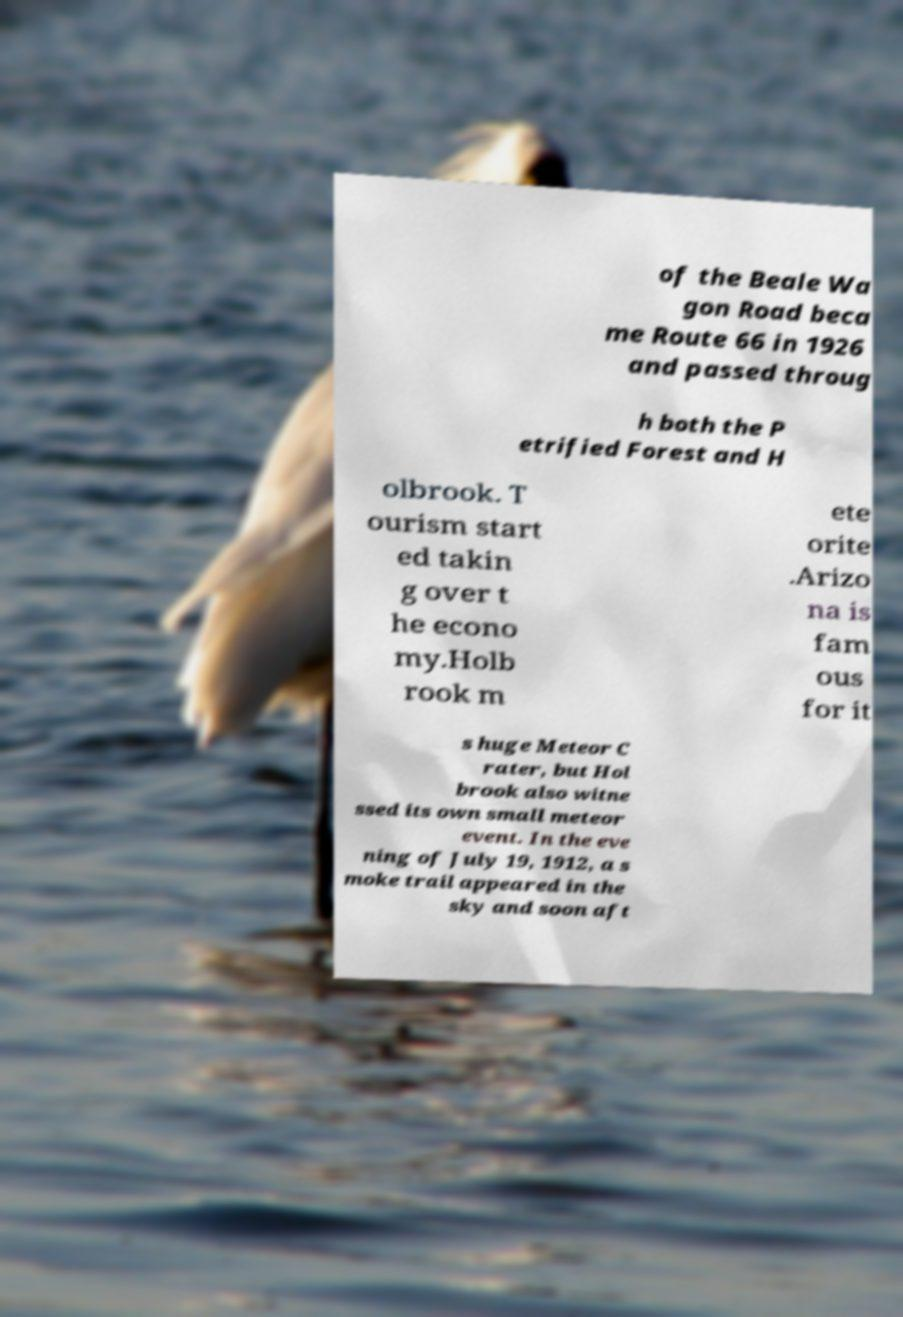Could you assist in decoding the text presented in this image and type it out clearly? of the Beale Wa gon Road beca me Route 66 in 1926 and passed throug h both the P etrified Forest and H olbrook. T ourism start ed takin g over t he econo my.Holb rook m ete orite .Arizo na is fam ous for it s huge Meteor C rater, but Hol brook also witne ssed its own small meteor event. In the eve ning of July 19, 1912, a s moke trail appeared in the sky and soon aft 